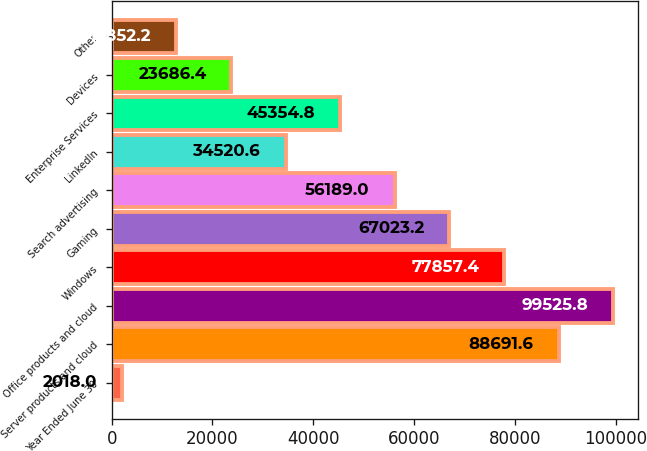<chart> <loc_0><loc_0><loc_500><loc_500><bar_chart><fcel>Year Ended June 30<fcel>Server products and cloud<fcel>Office products and cloud<fcel>Windows<fcel>Gaming<fcel>Search advertising<fcel>LinkedIn<fcel>Enterprise Services<fcel>Devices<fcel>Other<nl><fcel>2018<fcel>88691.6<fcel>99525.8<fcel>77857.4<fcel>67023.2<fcel>56189<fcel>34520.6<fcel>45354.8<fcel>23686.4<fcel>12852.2<nl></chart> 